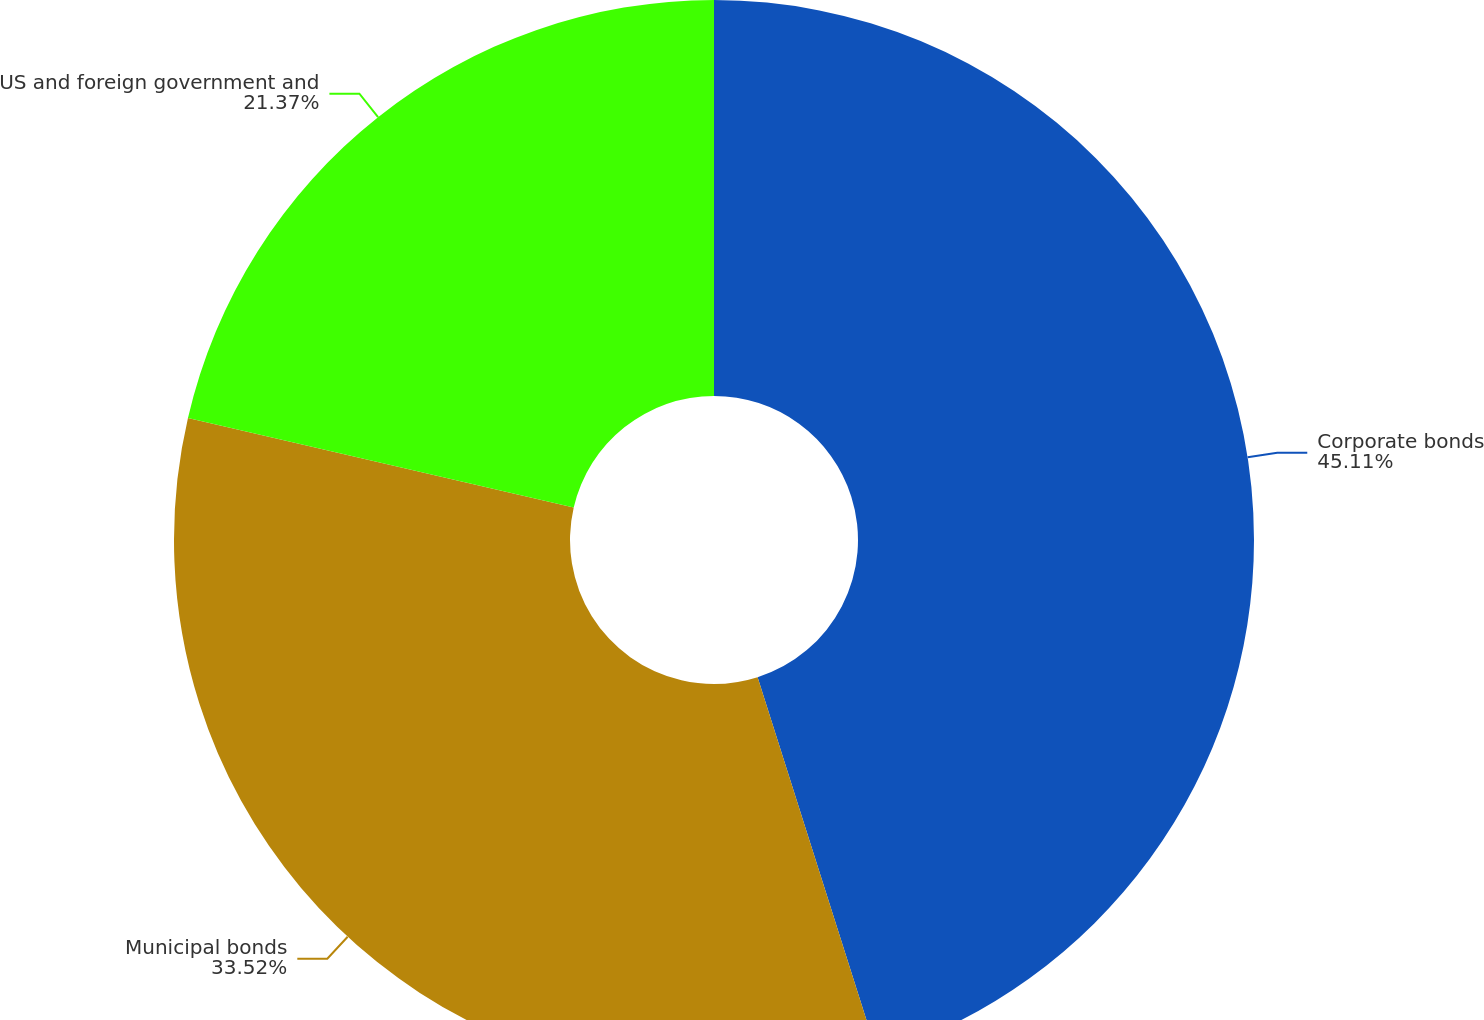Convert chart. <chart><loc_0><loc_0><loc_500><loc_500><pie_chart><fcel>Corporate bonds<fcel>Municipal bonds<fcel>US and foreign government and<nl><fcel>45.1%<fcel>33.52%<fcel>21.37%<nl></chart> 